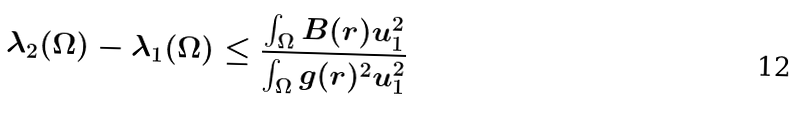<formula> <loc_0><loc_0><loc_500><loc_500>\lambda _ { 2 } ( \Omega ) - \lambda _ { 1 } ( \Omega ) \leq \frac { \int _ { \Omega } B ( r ) u ^ { 2 } _ { 1 } } { \int _ { \Omega } g ( r ) ^ { 2 } u ^ { 2 } _ { 1 } }</formula> 